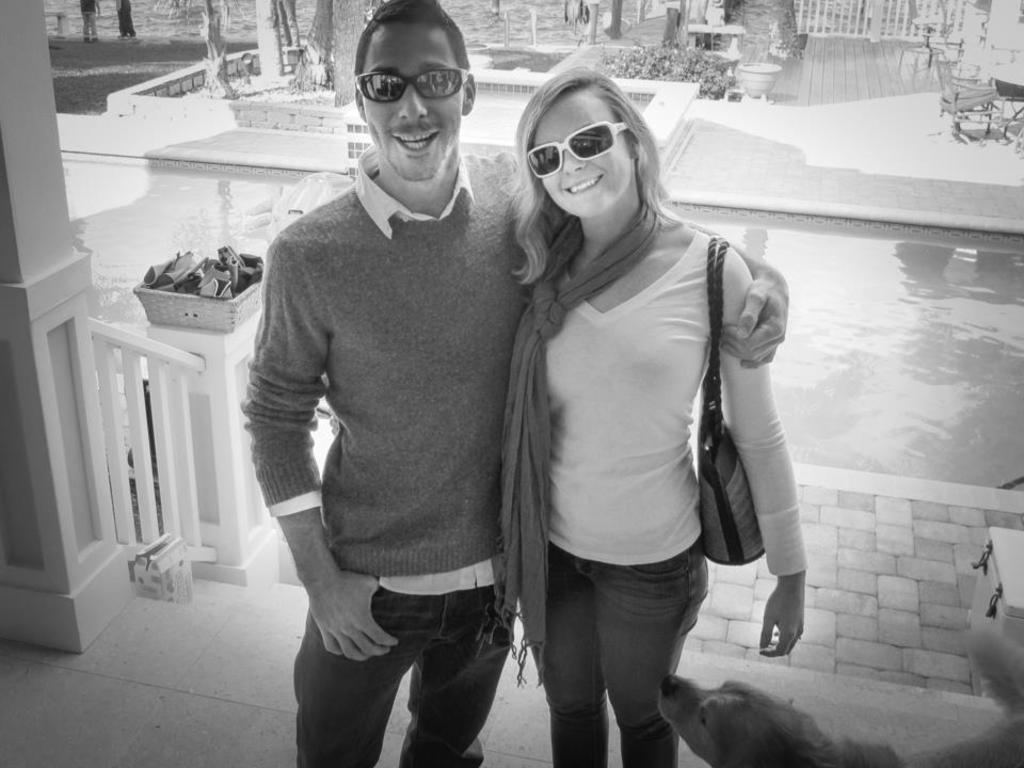How many people are in the image? There are two persons standing in the image. Can you describe one of the persons? One of the persons is a woman. What is the woman holding or carrying in the image? The woman is carrying a bag. What can be seen in the background of the image? There are objects in a basket and plants in the background of the image. Can you identify any animals in the image? Yes, there is a dog visible in the image. What is the woman's aunt doing in the background of the image? There is no mention of an aunt in the image, so we cannot answer this question. Why is the dog crying in the image? There is no indication that the dog is crying in the image; it is simply visible. 